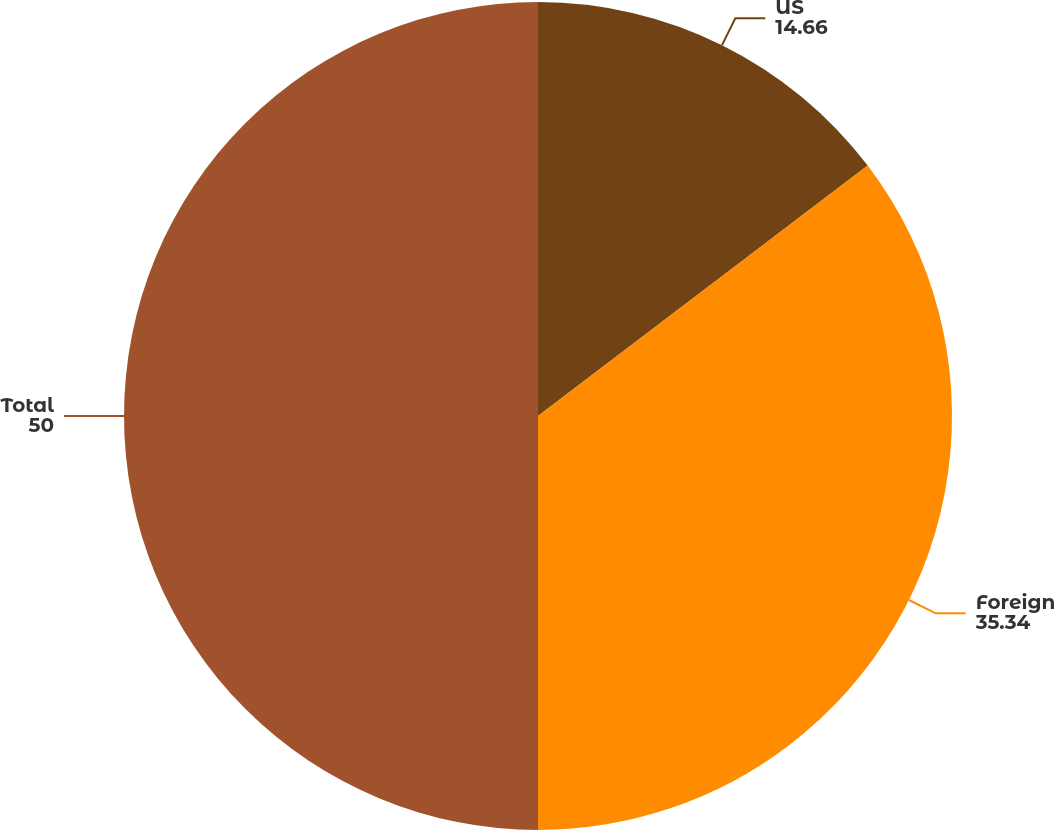Convert chart. <chart><loc_0><loc_0><loc_500><loc_500><pie_chart><fcel>US<fcel>Foreign<fcel>Total<nl><fcel>14.66%<fcel>35.34%<fcel>50.0%<nl></chart> 